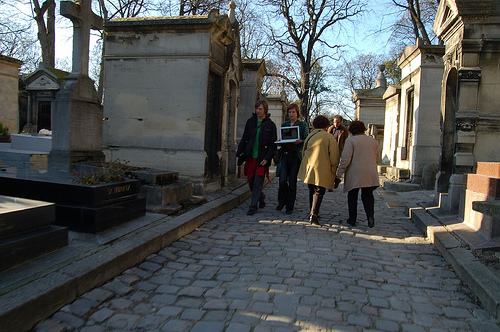<image>
Can you confirm if the man is behind the woman? Yes. From this viewpoint, the man is positioned behind the woman, with the woman partially or fully occluding the man. 